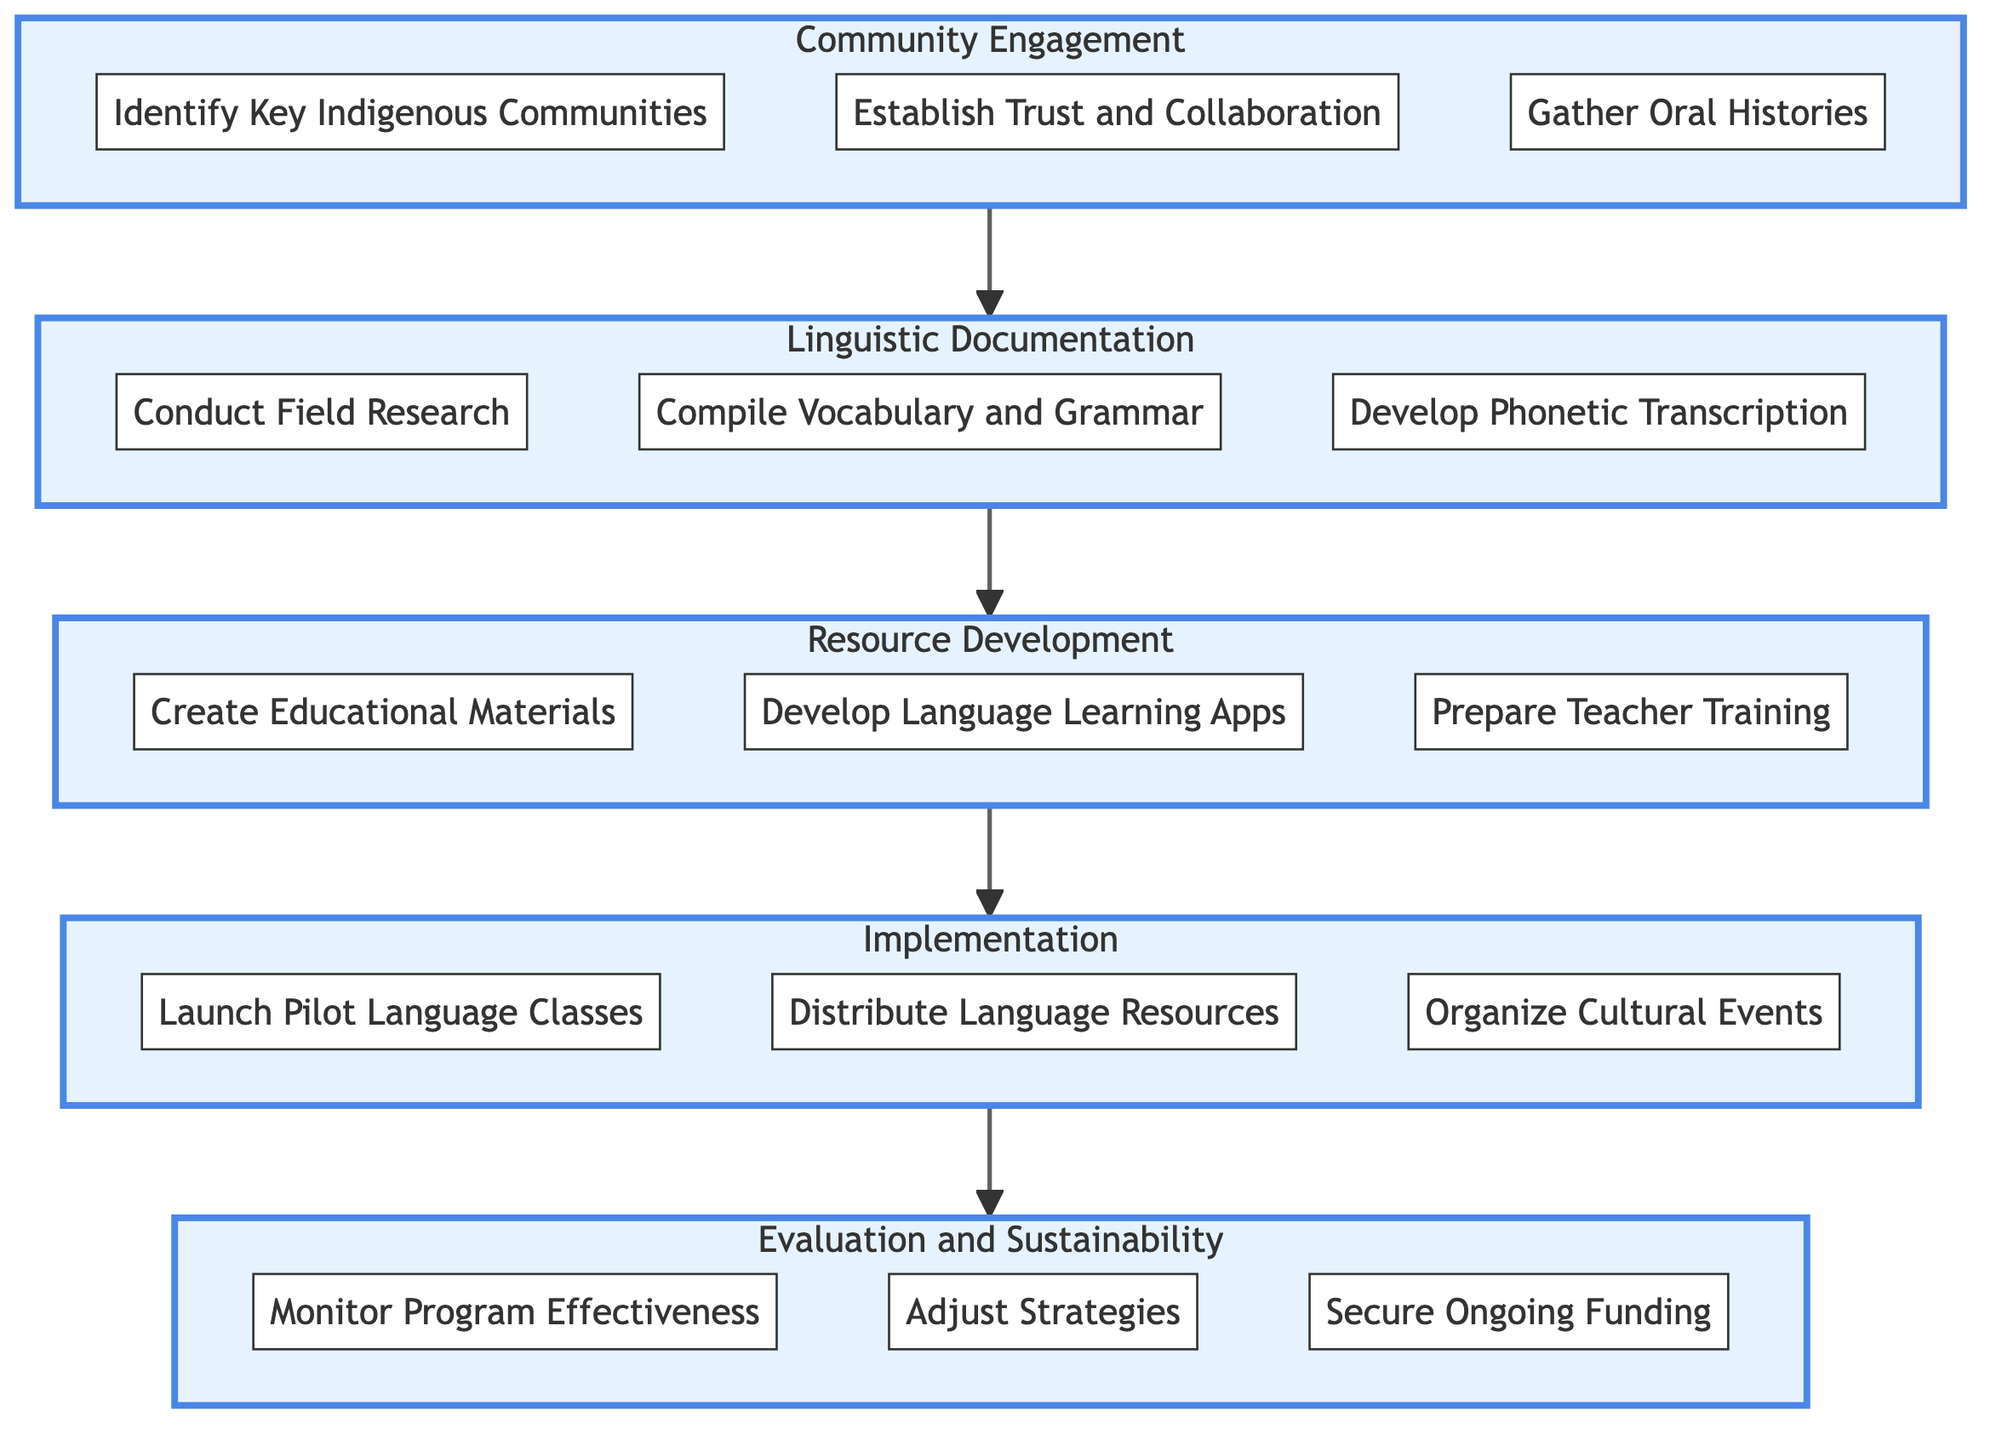What is the first step in the Clinical Pathway? The first step is labeled "Community Engagement." It is the initial node that initiates the Clinical Pathway flow.
Answer: Community Engagement How many tasks are there in the "Linguistic Documentation" step? The "Linguistic Documentation" step contains three specific tasks which are listed under it.
Answer: 3 What task follows "Gather Oral Histories and Cultural Practices"? The task that follows "Gather Oral Histories and Cultural Practices" is "Conduct Field Research and Record Native Speakers." This task is in the subsequent step "Linguistic Documentation."
Answer: Conduct Field Research and Record Native Speakers Which step includes the task "Create Educational Materials"? "Create Educational Materials" is included in the "Resource Development" step, as it is one of the tasks that fall under that subheading.
Answer: Resource Development How many total tasks are present in the entire Clinical Pathway? To find the total tasks, we can count each individual task in all steps: there are 15 tasks listed across all five steps.
Answer: 15 What is the last step of the Clinical Pathway? The last step is labeled "Evaluation and Sustainability," which is where the final phase of the process occurs.
Answer: Evaluation and Sustainability Which step comes before "Implementation"? The step that comes before "Implementation" is "Resource Development," as it precedes the stage of putting resources into action.
Answer: Resource Development What is the second task in the "Evaluation and Sustainability" step? The second task in the "Evaluation and Sustainability" step is "Adjust Strategies Based on Feedback," which comes after monitoring the program.
Answer: Adjust Strategies Based on Feedback How are the steps organized in the Clinical Pathway? The steps are organized in a linear sequence that flows from "Community Engagement" to "Evaluation and Sustainability," representing a continuous process.
Answer: Linear sequence 